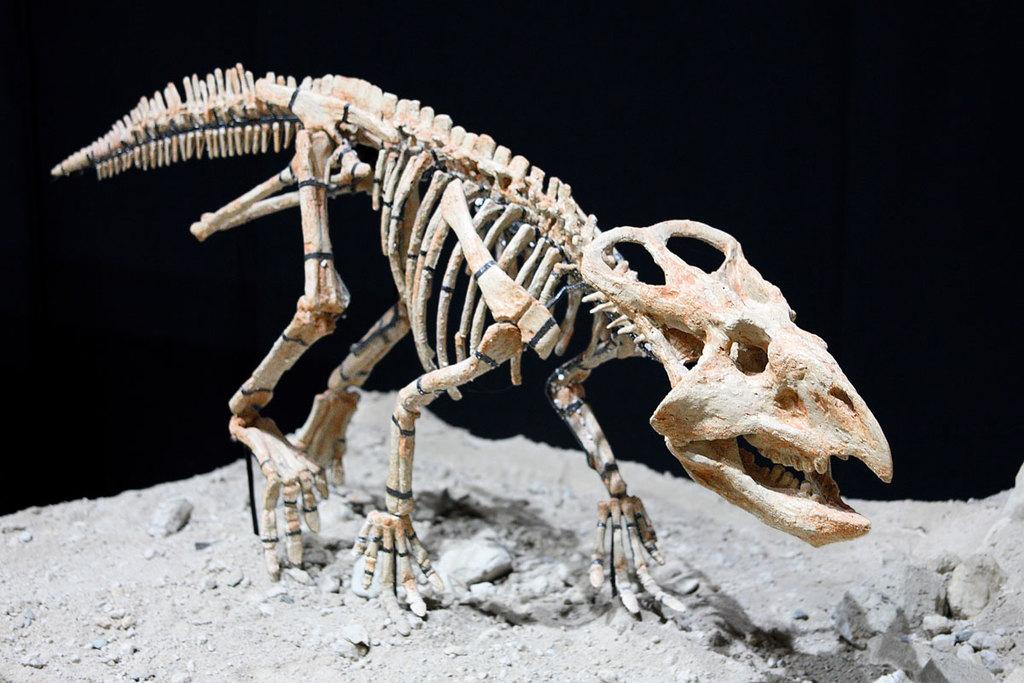What is the main subject of the image? The main subject of the image is a bone skeleton of a dinosaur. Where is the bone skeleton located in the image? The bone skeleton is placed on the ground. What type of lipstick is the dinosaur wearing in the image? There is no lipstick or dinosaur wearing lipstick present in the image. 